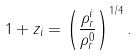<formula> <loc_0><loc_0><loc_500><loc_500>1 + z _ { i } = \left ( \frac { \rho _ { r } ^ { i } } { \rho _ { r } ^ { 0 } } \right ) ^ { 1 / 4 } .</formula> 